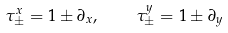Convert formula to latex. <formula><loc_0><loc_0><loc_500><loc_500>\tau ^ { x } _ { \pm } = { 1 } \pm \partial _ { x } , \quad \tau ^ { y } _ { \pm } = { 1 } \pm \partial _ { y }</formula> 